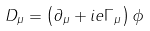Convert formula to latex. <formula><loc_0><loc_0><loc_500><loc_500>D _ { \mu } = \left ( \partial _ { \mu } + i e \Gamma _ { \mu } \right ) \phi</formula> 